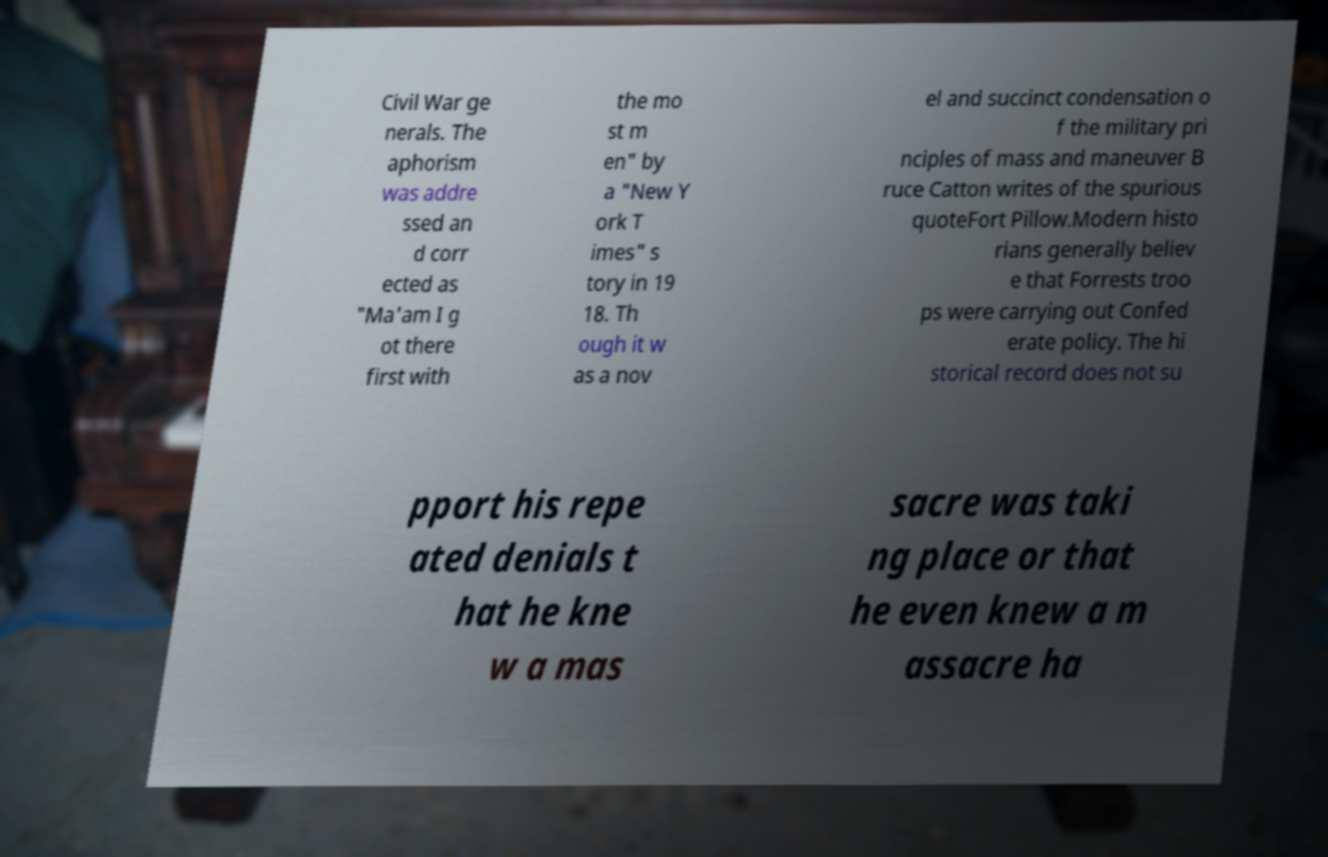Can you explain the significance of the mention of 'Fort Pillow' in this context? Fort Pillow refers to the Fort Pillow Massacre during the American Civil War, where Confederate forces under General Nathan Bedford Forrest are said to have killed over 300 African-American Union soldiers after they had surrendered. The text hints at ongoing debates among historians about whether Forrest was aware of or sanctioned these actions, reflecting on themes of leadership responsibility and the morality of wartime conduct. 